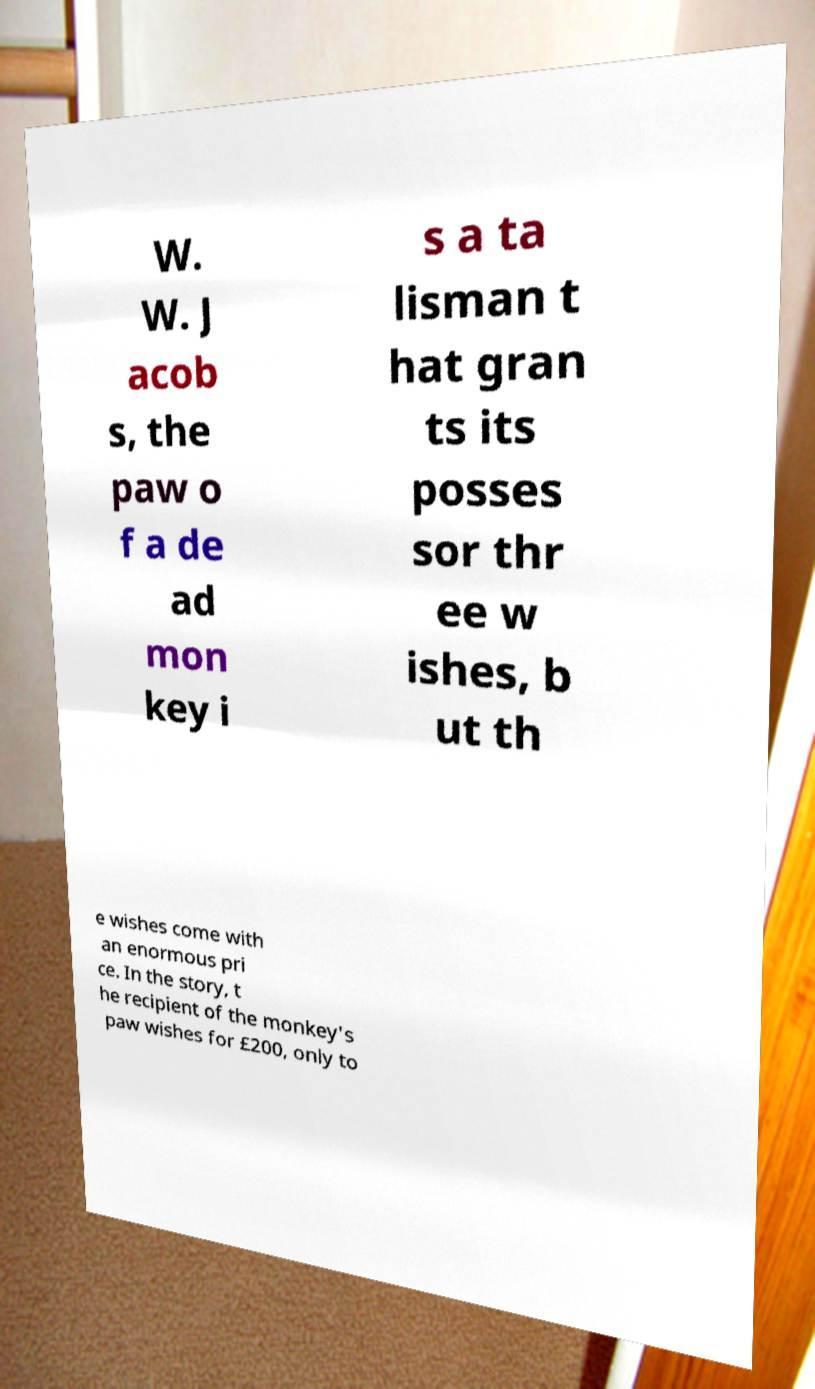For documentation purposes, I need the text within this image transcribed. Could you provide that? W. W. J acob s, the paw o f a de ad mon key i s a ta lisman t hat gran ts its posses sor thr ee w ishes, b ut th e wishes come with an enormous pri ce. In the story, t he recipient of the monkey's paw wishes for £200, only to 